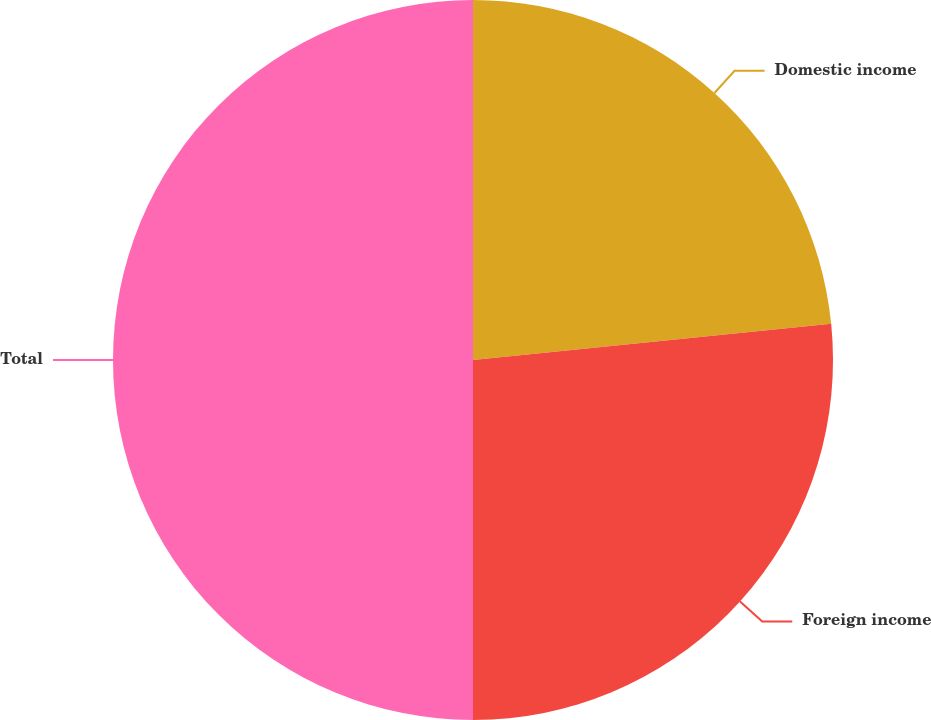<chart> <loc_0><loc_0><loc_500><loc_500><pie_chart><fcel>Domestic income<fcel>Foreign income<fcel>Total<nl><fcel>23.4%<fcel>26.6%<fcel>50.0%<nl></chart> 